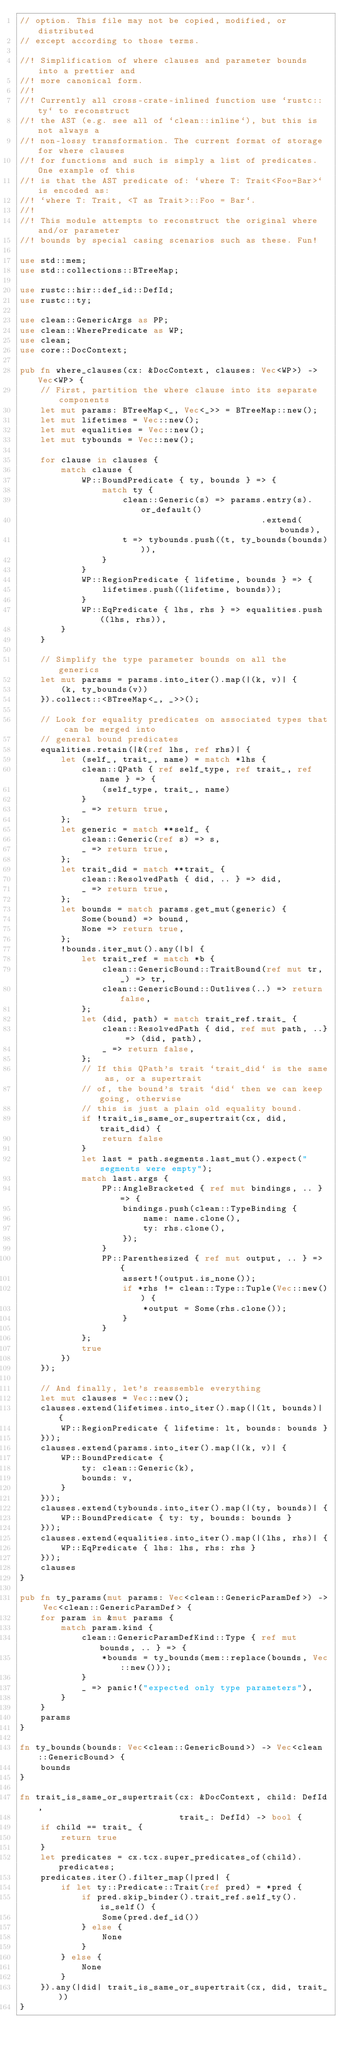<code> <loc_0><loc_0><loc_500><loc_500><_Rust_>// option. This file may not be copied, modified, or distributed
// except according to those terms.

//! Simplification of where clauses and parameter bounds into a prettier and
//! more canonical form.
//!
//! Currently all cross-crate-inlined function use `rustc::ty` to reconstruct
//! the AST (e.g. see all of `clean::inline`), but this is not always a
//! non-lossy transformation. The current format of storage for where clauses
//! for functions and such is simply a list of predicates. One example of this
//! is that the AST predicate of: `where T: Trait<Foo=Bar>` is encoded as:
//! `where T: Trait, <T as Trait>::Foo = Bar`.
//!
//! This module attempts to reconstruct the original where and/or parameter
//! bounds by special casing scenarios such as these. Fun!

use std::mem;
use std::collections::BTreeMap;

use rustc::hir::def_id::DefId;
use rustc::ty;

use clean::GenericArgs as PP;
use clean::WherePredicate as WP;
use clean;
use core::DocContext;

pub fn where_clauses(cx: &DocContext, clauses: Vec<WP>) -> Vec<WP> {
    // First, partition the where clause into its separate components
    let mut params: BTreeMap<_, Vec<_>> = BTreeMap::new();
    let mut lifetimes = Vec::new();
    let mut equalities = Vec::new();
    let mut tybounds = Vec::new();

    for clause in clauses {
        match clause {
            WP::BoundPredicate { ty, bounds } => {
                match ty {
                    clean::Generic(s) => params.entry(s).or_default()
                                               .extend(bounds),
                    t => tybounds.push((t, ty_bounds(bounds))),
                }
            }
            WP::RegionPredicate { lifetime, bounds } => {
                lifetimes.push((lifetime, bounds));
            }
            WP::EqPredicate { lhs, rhs } => equalities.push((lhs, rhs)),
        }
    }

    // Simplify the type parameter bounds on all the generics
    let mut params = params.into_iter().map(|(k, v)| {
        (k, ty_bounds(v))
    }).collect::<BTreeMap<_, _>>();

    // Look for equality predicates on associated types that can be merged into
    // general bound predicates
    equalities.retain(|&(ref lhs, ref rhs)| {
        let (self_, trait_, name) = match *lhs {
            clean::QPath { ref self_type, ref trait_, ref name } => {
                (self_type, trait_, name)
            }
            _ => return true,
        };
        let generic = match **self_ {
            clean::Generic(ref s) => s,
            _ => return true,
        };
        let trait_did = match **trait_ {
            clean::ResolvedPath { did, .. } => did,
            _ => return true,
        };
        let bounds = match params.get_mut(generic) {
            Some(bound) => bound,
            None => return true,
        };
        !bounds.iter_mut().any(|b| {
            let trait_ref = match *b {
                clean::GenericBound::TraitBound(ref mut tr, _) => tr,
                clean::GenericBound::Outlives(..) => return false,
            };
            let (did, path) = match trait_ref.trait_ {
                clean::ResolvedPath { did, ref mut path, ..} => (did, path),
                _ => return false,
            };
            // If this QPath's trait `trait_did` is the same as, or a supertrait
            // of, the bound's trait `did` then we can keep going, otherwise
            // this is just a plain old equality bound.
            if !trait_is_same_or_supertrait(cx, did, trait_did) {
                return false
            }
            let last = path.segments.last_mut().expect("segments were empty");
            match last.args {
                PP::AngleBracketed { ref mut bindings, .. } => {
                    bindings.push(clean::TypeBinding {
                        name: name.clone(),
                        ty: rhs.clone(),
                    });
                }
                PP::Parenthesized { ref mut output, .. } => {
                    assert!(output.is_none());
                    if *rhs != clean::Type::Tuple(Vec::new()) {
                        *output = Some(rhs.clone());
                    }
                }
            };
            true
        })
    });

    // And finally, let's reassemble everything
    let mut clauses = Vec::new();
    clauses.extend(lifetimes.into_iter().map(|(lt, bounds)| {
        WP::RegionPredicate { lifetime: lt, bounds: bounds }
    }));
    clauses.extend(params.into_iter().map(|(k, v)| {
        WP::BoundPredicate {
            ty: clean::Generic(k),
            bounds: v,
        }
    }));
    clauses.extend(tybounds.into_iter().map(|(ty, bounds)| {
        WP::BoundPredicate { ty: ty, bounds: bounds }
    }));
    clauses.extend(equalities.into_iter().map(|(lhs, rhs)| {
        WP::EqPredicate { lhs: lhs, rhs: rhs }
    }));
    clauses
}

pub fn ty_params(mut params: Vec<clean::GenericParamDef>) -> Vec<clean::GenericParamDef> {
    for param in &mut params {
        match param.kind {
            clean::GenericParamDefKind::Type { ref mut bounds, .. } => {
                *bounds = ty_bounds(mem::replace(bounds, Vec::new()));
            }
            _ => panic!("expected only type parameters"),
        }
    }
    params
}

fn ty_bounds(bounds: Vec<clean::GenericBound>) -> Vec<clean::GenericBound> {
    bounds
}

fn trait_is_same_or_supertrait(cx: &DocContext, child: DefId,
                               trait_: DefId) -> bool {
    if child == trait_ {
        return true
    }
    let predicates = cx.tcx.super_predicates_of(child).predicates;
    predicates.iter().filter_map(|pred| {
        if let ty::Predicate::Trait(ref pred) = *pred {
            if pred.skip_binder().trait_ref.self_ty().is_self() {
                Some(pred.def_id())
            } else {
                None
            }
        } else {
            None
        }
    }).any(|did| trait_is_same_or_supertrait(cx, did, trait_))
}
</code> 